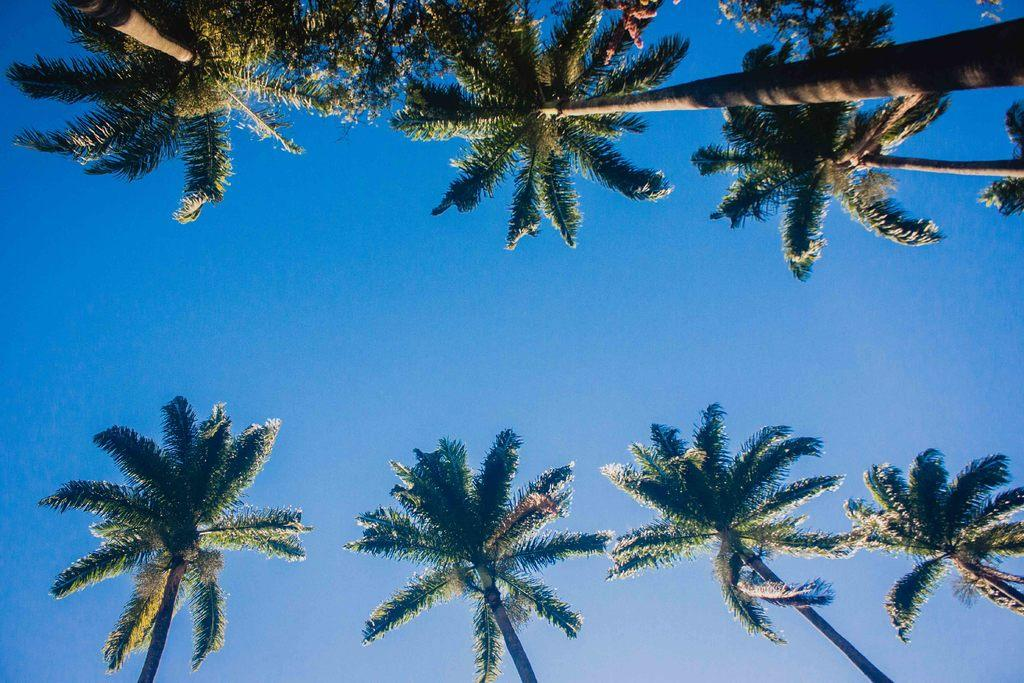What type of vegetation can be seen in the image? There are trees in the image. What color are the trees in the image? The trees are green in color. What can be seen in the background of the image? The sky is visible in the background of the image. What color is the sky in the image? The sky is blue in color. How many pigs are visible in the image? There are no pigs present in the image. What type of unit is being measured in the image? There is no unit being measured in the image. 